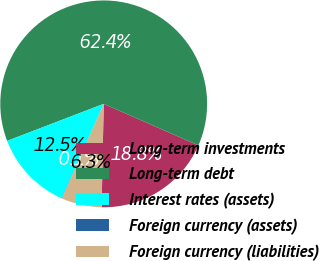<chart> <loc_0><loc_0><loc_500><loc_500><pie_chart><fcel>Long-term investments<fcel>Long-term debt<fcel>Interest rates (assets)<fcel>Foreign currency (assets)<fcel>Foreign currency (liabilities)<nl><fcel>18.75%<fcel>62.4%<fcel>12.52%<fcel>0.05%<fcel>6.28%<nl></chart> 